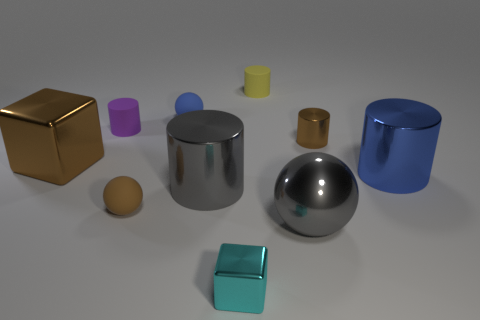How many other objects are there of the same size as the brown shiny cube?
Provide a succinct answer. 3. There is a thing that is both on the left side of the blue ball and in front of the big metallic block; how big is it?
Your answer should be compact. Small. How many other objects have the same shape as the small brown matte object?
Offer a terse response. 2. What material is the large gray sphere?
Give a very brief answer. Metal. Is the yellow thing the same shape as the purple matte object?
Offer a very short reply. Yes. Is there a sphere that has the same material as the yellow cylinder?
Your response must be concise. Yes. There is a tiny object that is both to the left of the blue rubber sphere and in front of the brown cylinder; what is its color?
Offer a very short reply. Brown. There is a blue object that is in front of the tiny metallic cylinder; what material is it?
Ensure brevity in your answer.  Metal. Are there any brown shiny objects of the same shape as the small purple matte object?
Give a very brief answer. Yes. How many other things are the same shape as the big blue thing?
Make the answer very short. 4. 